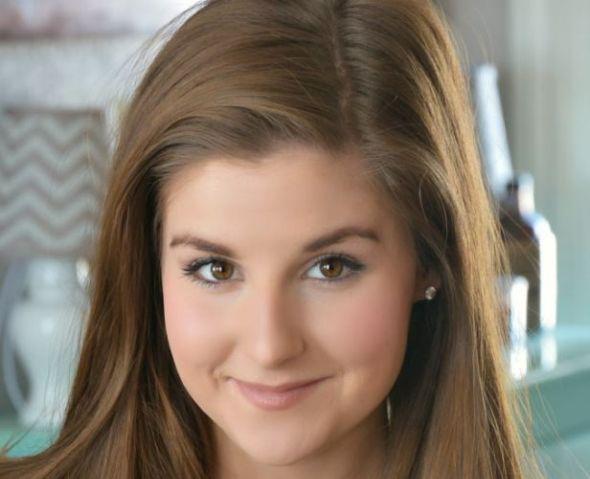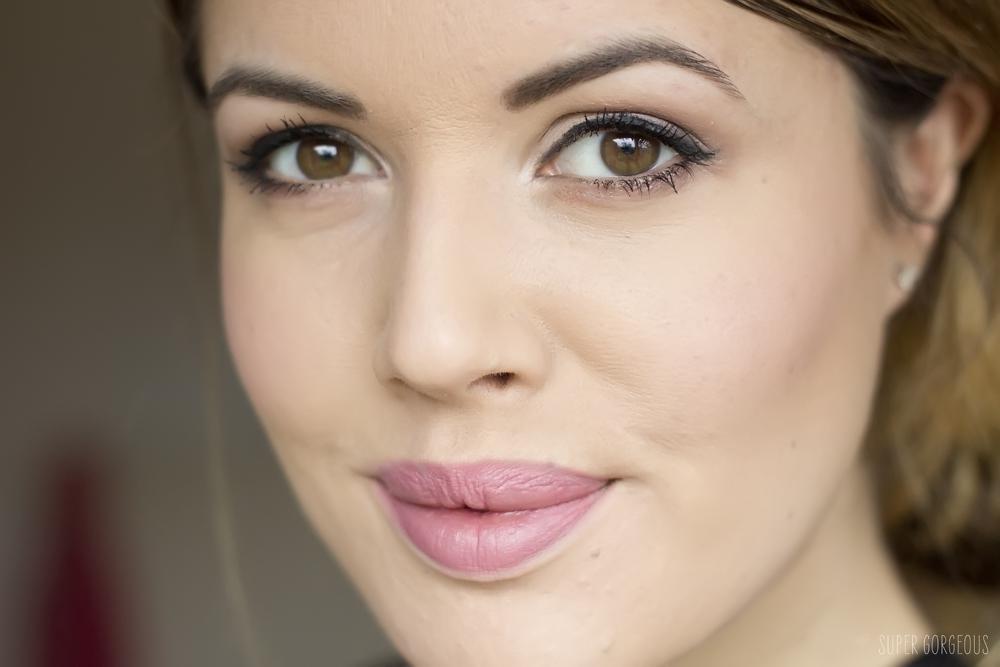The first image is the image on the left, the second image is the image on the right. Assess this claim about the two images: "Three people are visible in the two images.". Correct or not? Answer yes or no. No. 